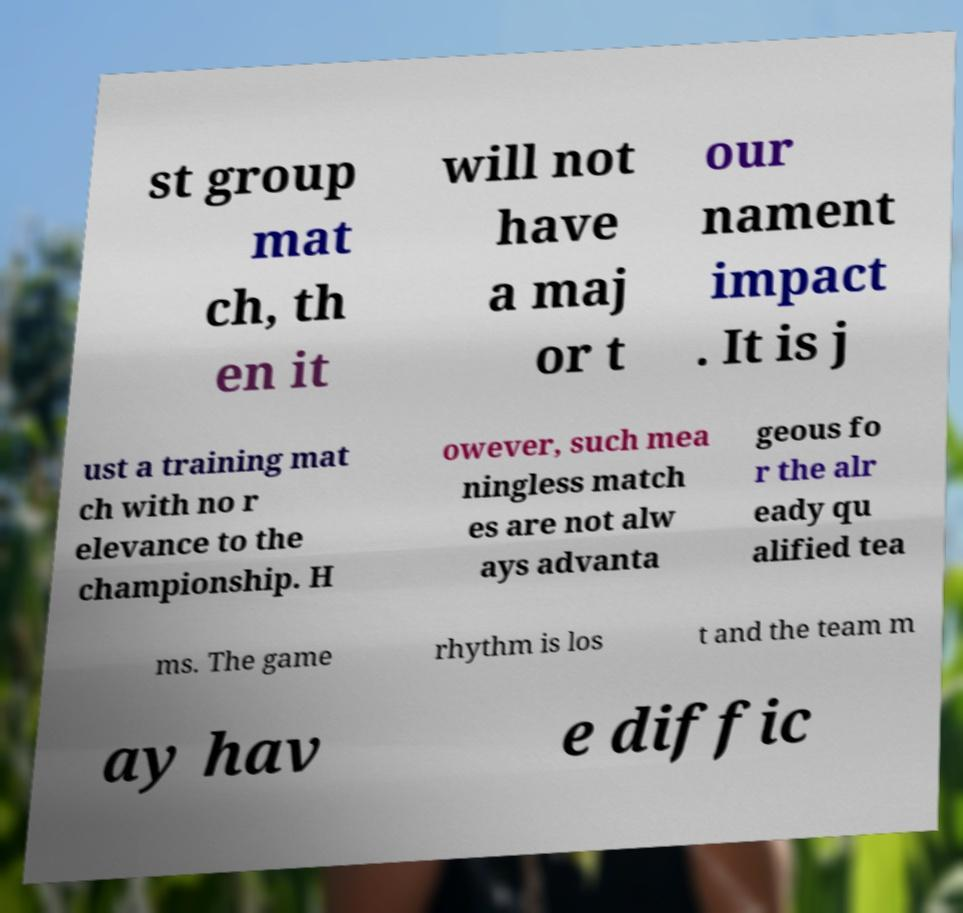What messages or text are displayed in this image? I need them in a readable, typed format. st group mat ch, th en it will not have a maj or t our nament impact . It is j ust a training mat ch with no r elevance to the championship. H owever, such mea ningless match es are not alw ays advanta geous fo r the alr eady qu alified tea ms. The game rhythm is los t and the team m ay hav e diffic 